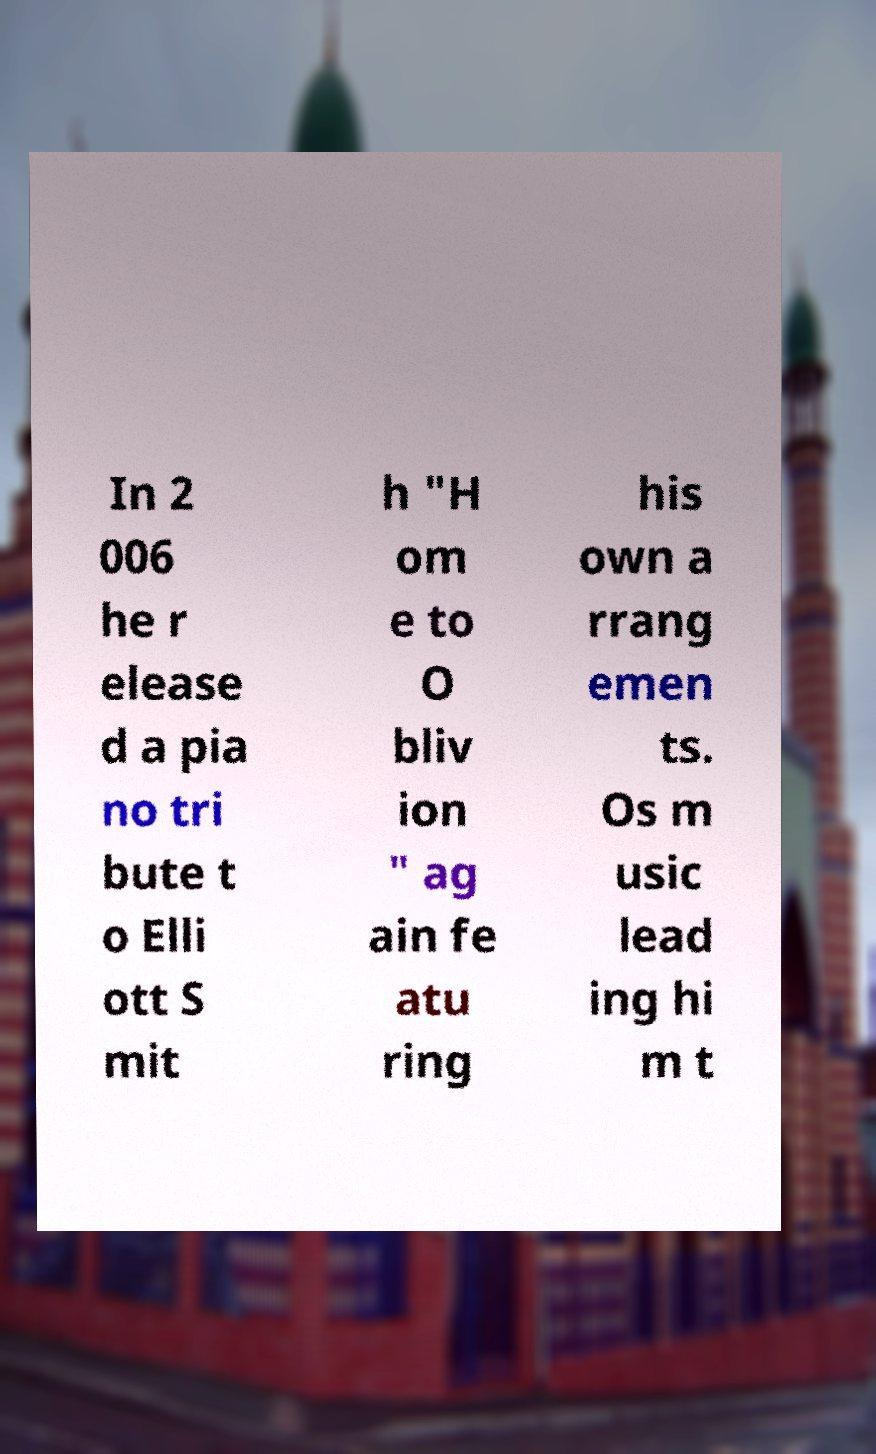Can you accurately transcribe the text from the provided image for me? In 2 006 he r elease d a pia no tri bute t o Elli ott S mit h "H om e to O bliv ion " ag ain fe atu ring his own a rrang emen ts. Os m usic lead ing hi m t 